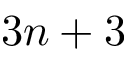Convert formula to latex. <formula><loc_0><loc_0><loc_500><loc_500>3 n + 3</formula> 